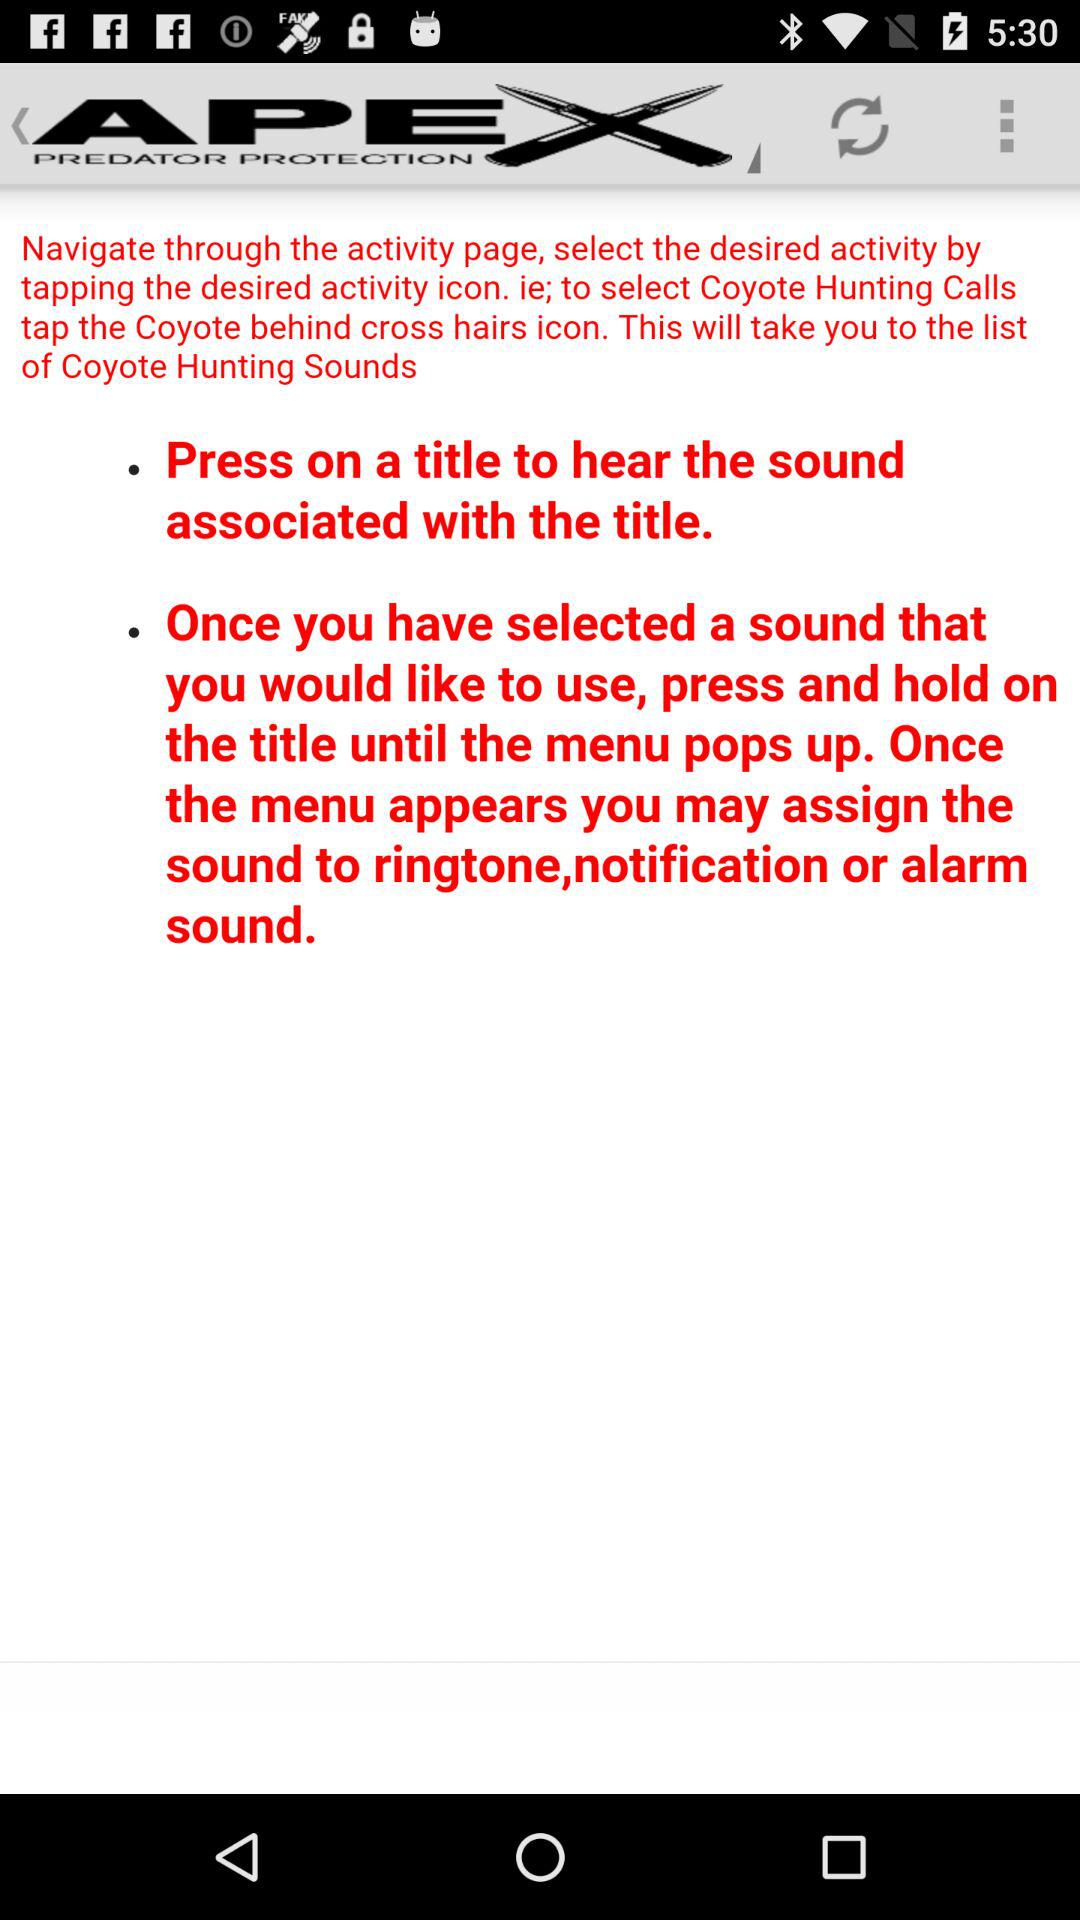What is the application name? The application name is "APEX PREDATOR PROTECTION". 